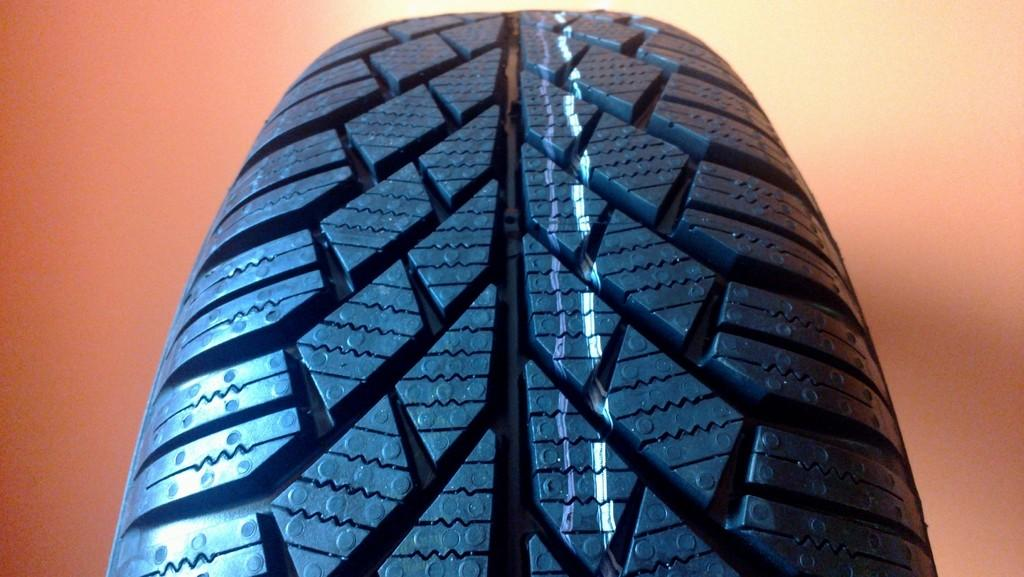What object is the main focus of the image? The main focus of the image is a tire. Can you describe the color of the tire? The tire is black in color. How many wrens can be seen perched on the tire in the image? There are no wrens present in the image, so it is not possible to determine how many there might be. 